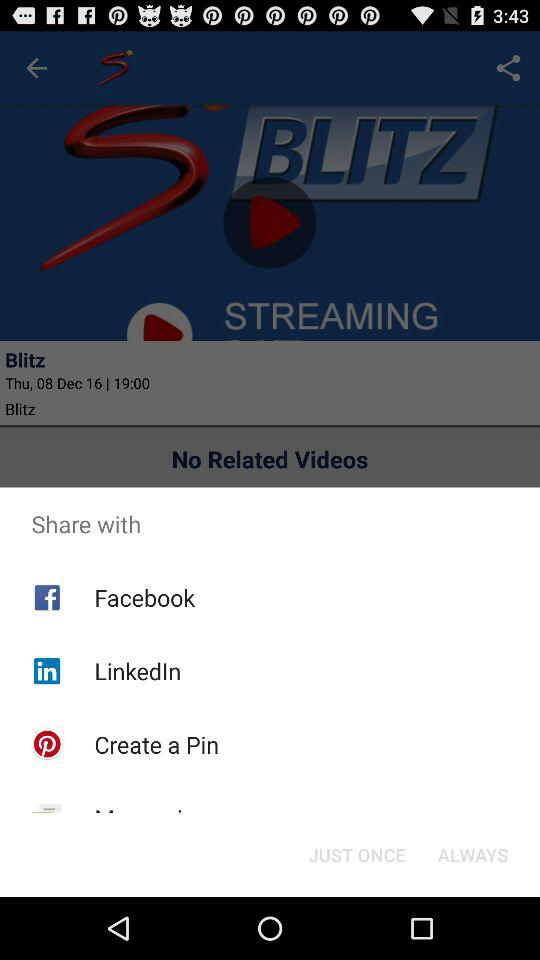What are the different mediums to share? The different mediums are "Facebook", "LinkedIn" and "Create a Pin". 